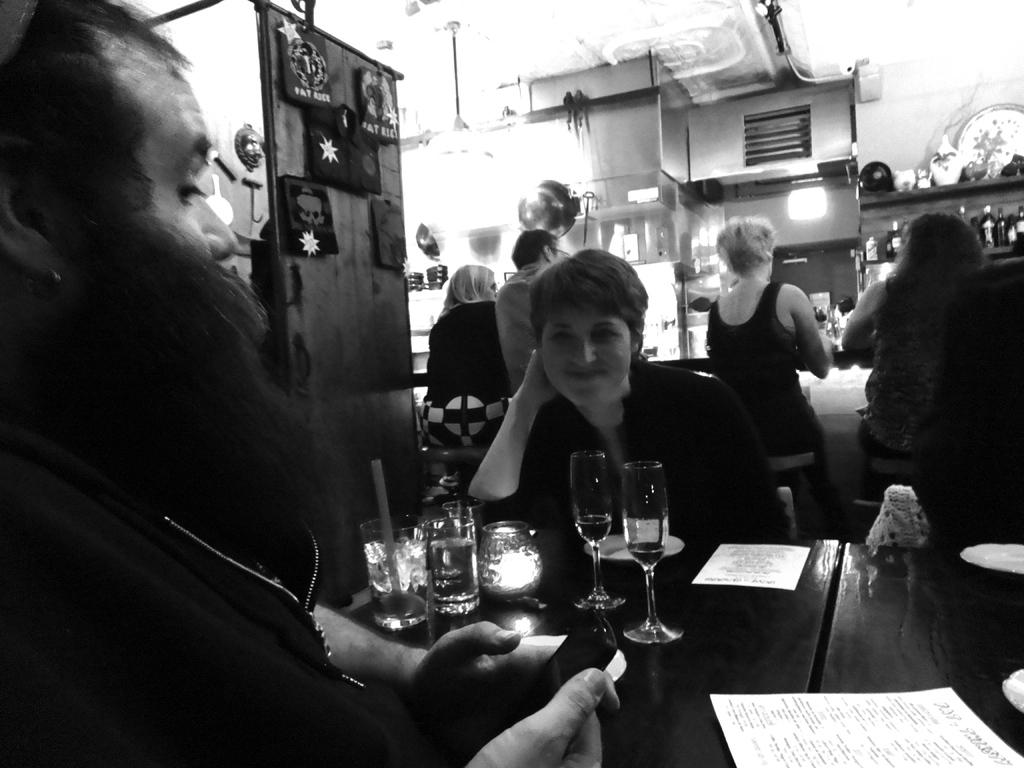What are the people in the image doing? There are people seated on chairs in the image. What is on the table in the image? There are papers, two wine glasses, and a bottle on the table in the image. Can you describe the man standing in the image? There is a man standing in the image. How are some of the people positioned in the image? There are people seated on their backs in the image. Where is the tent located in the image? There is no tent present in the image. What is the mailbox's rate for sending letters in the image? There is no mailbox present in the image, so it is not possible to determine its rate for sending letters. 